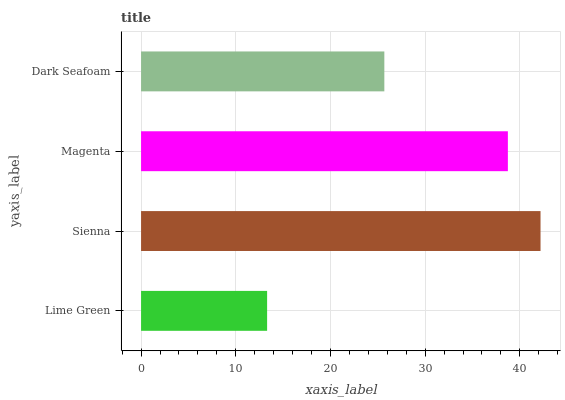Is Lime Green the minimum?
Answer yes or no. Yes. Is Sienna the maximum?
Answer yes or no. Yes. Is Magenta the minimum?
Answer yes or no. No. Is Magenta the maximum?
Answer yes or no. No. Is Sienna greater than Magenta?
Answer yes or no. Yes. Is Magenta less than Sienna?
Answer yes or no. Yes. Is Magenta greater than Sienna?
Answer yes or no. No. Is Sienna less than Magenta?
Answer yes or no. No. Is Magenta the high median?
Answer yes or no. Yes. Is Dark Seafoam the low median?
Answer yes or no. Yes. Is Dark Seafoam the high median?
Answer yes or no. No. Is Sienna the low median?
Answer yes or no. No. 